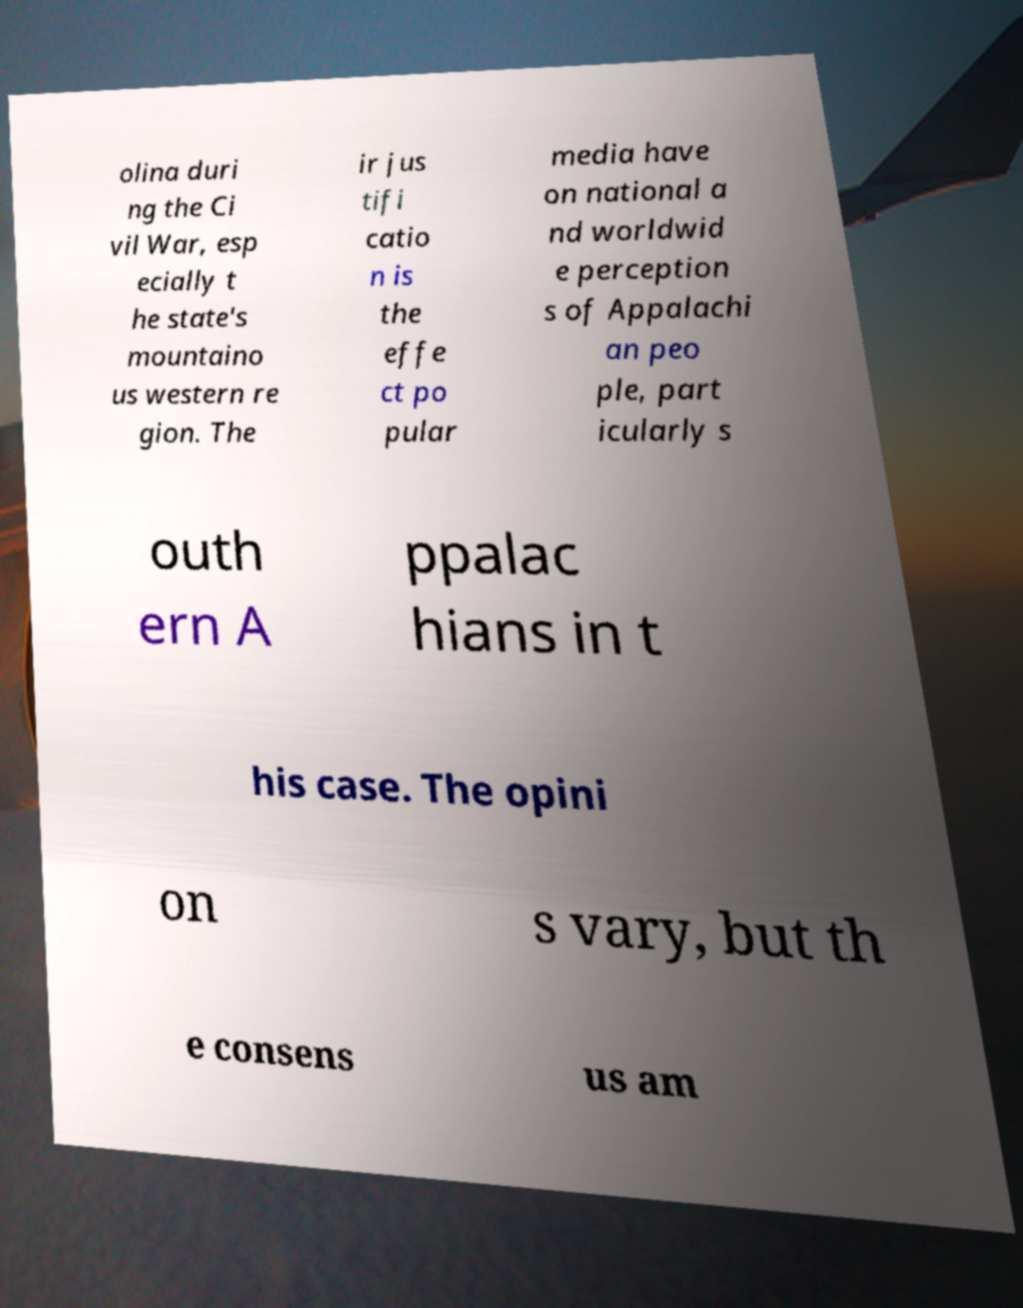Can you read and provide the text displayed in the image?This photo seems to have some interesting text. Can you extract and type it out for me? olina duri ng the Ci vil War, esp ecially t he state's mountaino us western re gion. The ir jus tifi catio n is the effe ct po pular media have on national a nd worldwid e perception s of Appalachi an peo ple, part icularly s outh ern A ppalac hians in t his case. The opini on s vary, but th e consens us am 